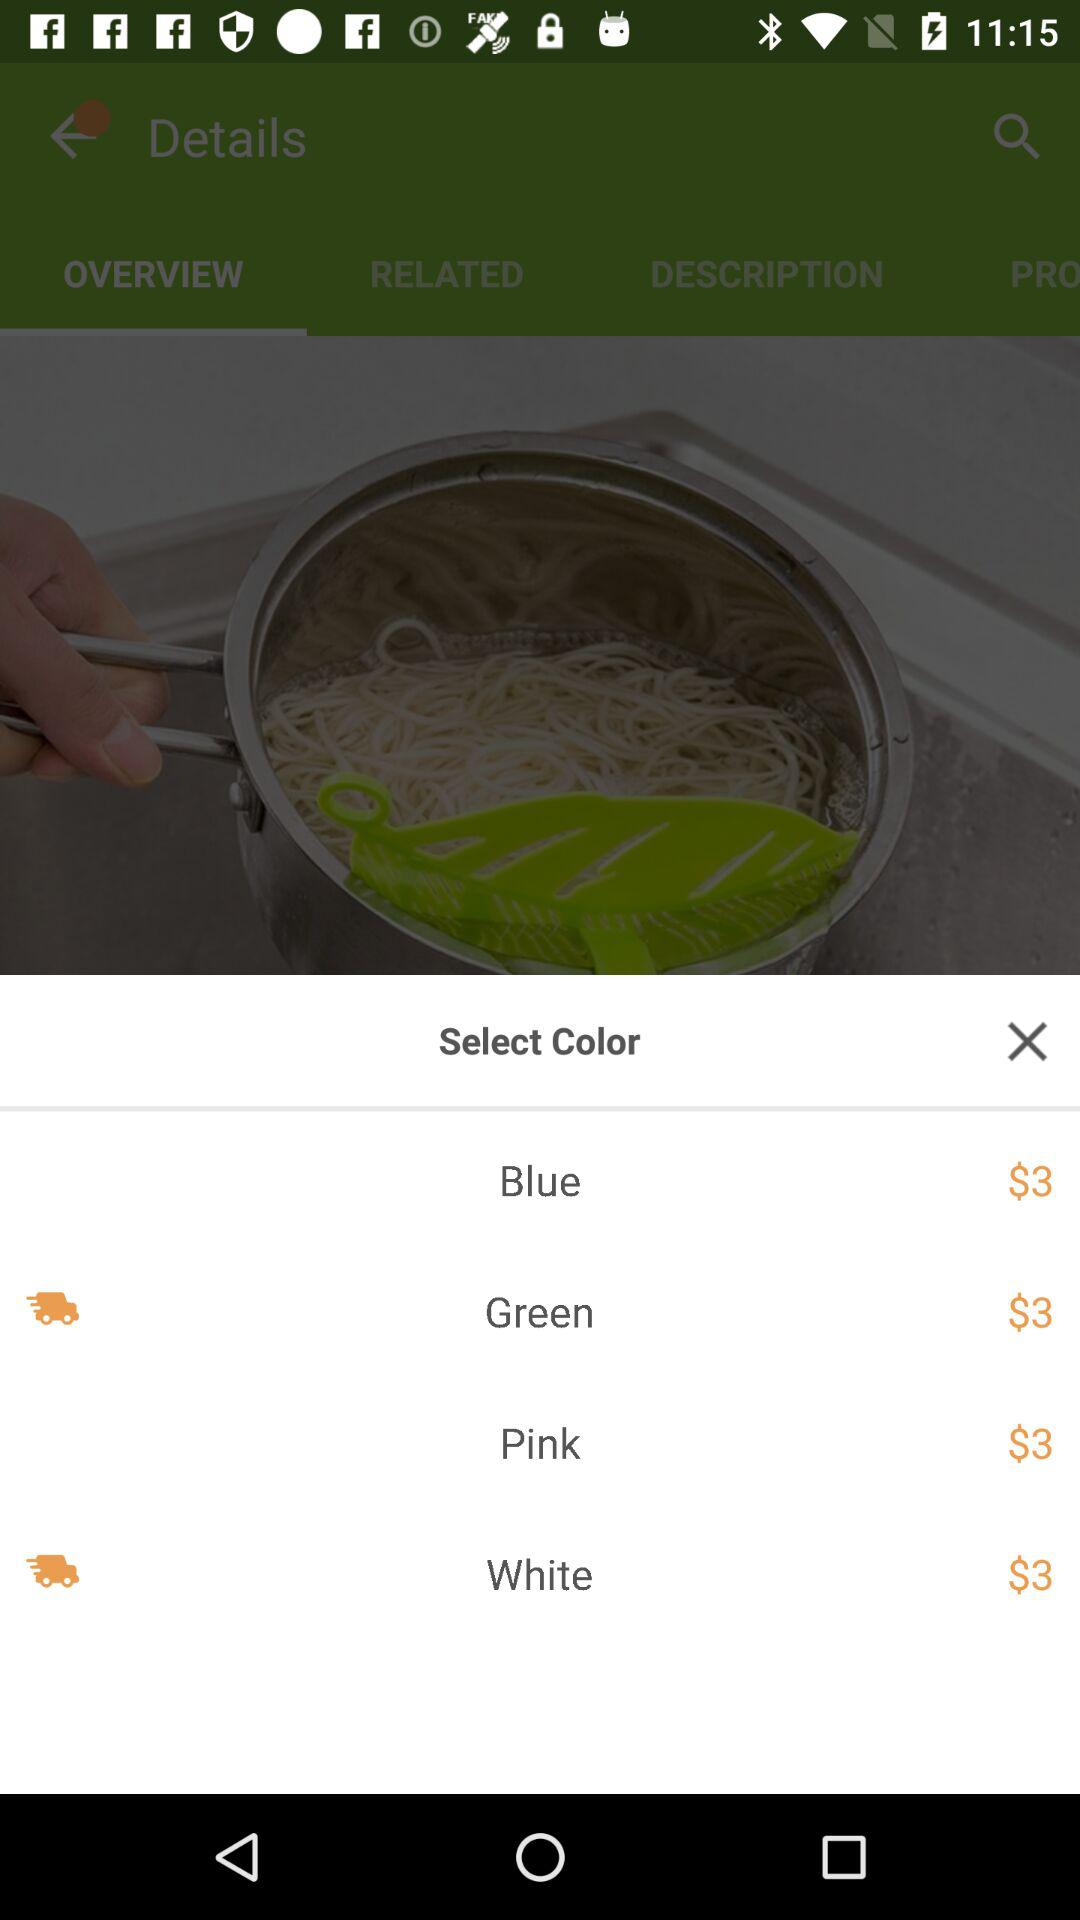What is the price of the product in the green color? The price of the product in the green color is $3. 